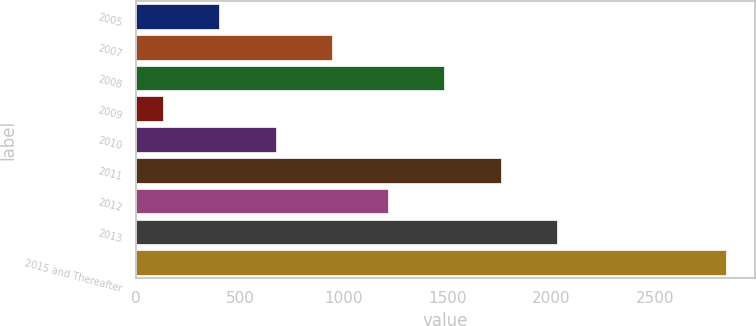Convert chart to OTSL. <chart><loc_0><loc_0><loc_500><loc_500><bar_chart><fcel>2005<fcel>2007<fcel>2008<fcel>2009<fcel>2010<fcel>2011<fcel>2012<fcel>2013<fcel>2015 and Thereafter<nl><fcel>401.1<fcel>943.3<fcel>1485.5<fcel>130<fcel>672.2<fcel>1756.6<fcel>1214.4<fcel>2027.7<fcel>2841<nl></chart> 